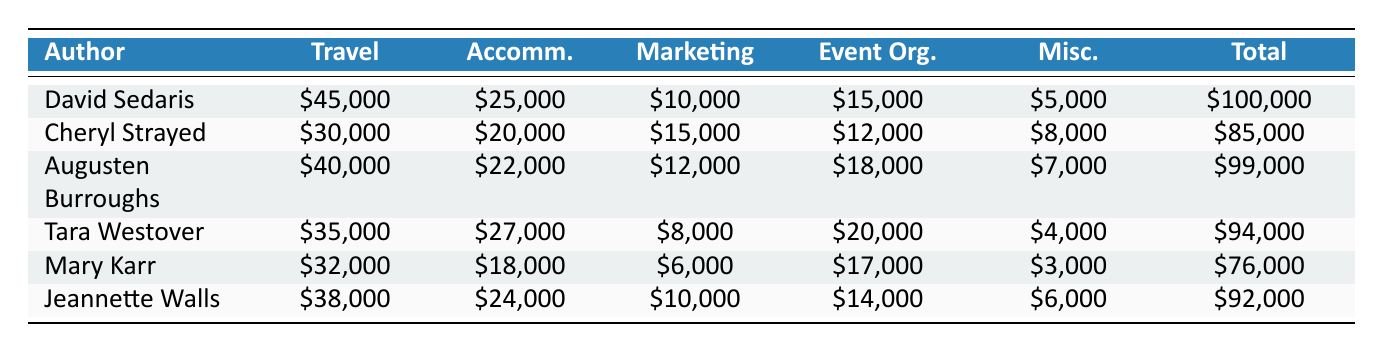What is the total expenditure for David Sedaris? The table lists David Sedaris' total expenditure under the "Total" column as $100,000.
Answer: 100000 Which author spent the least on accommodation? By comparing the "Accommodation" expenses of each author, Mary Karr spent $18,000, which is the lowest amount listed.
Answer: 18000 What is the difference between the total expenditures of Tara Westover and Augusten Burroughs? Tara Westover's total expenditure is $94,000, and Augusten Burroughs' is $99,000. The difference is 99,000 - 94,000 = 5,000.
Answer: 5000 Did Jeannette Walls spend more on travel than Cheryl Strayed? Jeannette Walls spent $38,000 on travel, while Cheryl Strayed spent $30,000. Since 38,000 is greater than 30,000, the answer is yes.
Answer: Yes What is the average travel expenditure of all authors? To calculate the average travel expenditure, we add the travel expenses: 45,000 + 30,000 + 40,000 + 35,000 + 32,000 + 38,000 = 210,000. Then, we divide by the number of authors (6): 210,000 / 6 = 35,000.
Answer: 35000 Which author has the highest marketing expenditure? The "Marketing" expenditures show that Cheryl Strayed spent $15,000, which is the highest amount in that column, compared to other authors.
Answer: 15000 What are the total miscellaneous expenses of all authors combined? To find the total miscellaneous expenses, we add them together: 5,000 + 8,000 + 7,000 + 4,000 + 3,000 + 6,000 = 33,000.
Answer: 33000 Is the total expenditure for David Sedaris the highest among all authors? David Sedaris' total expenditure is $100,000. By comparing it with others, Augusten Burroughs spent $99,000, and other authors spent less. Thus, David Sedaris has the highest expenditure.
Answer: Yes 